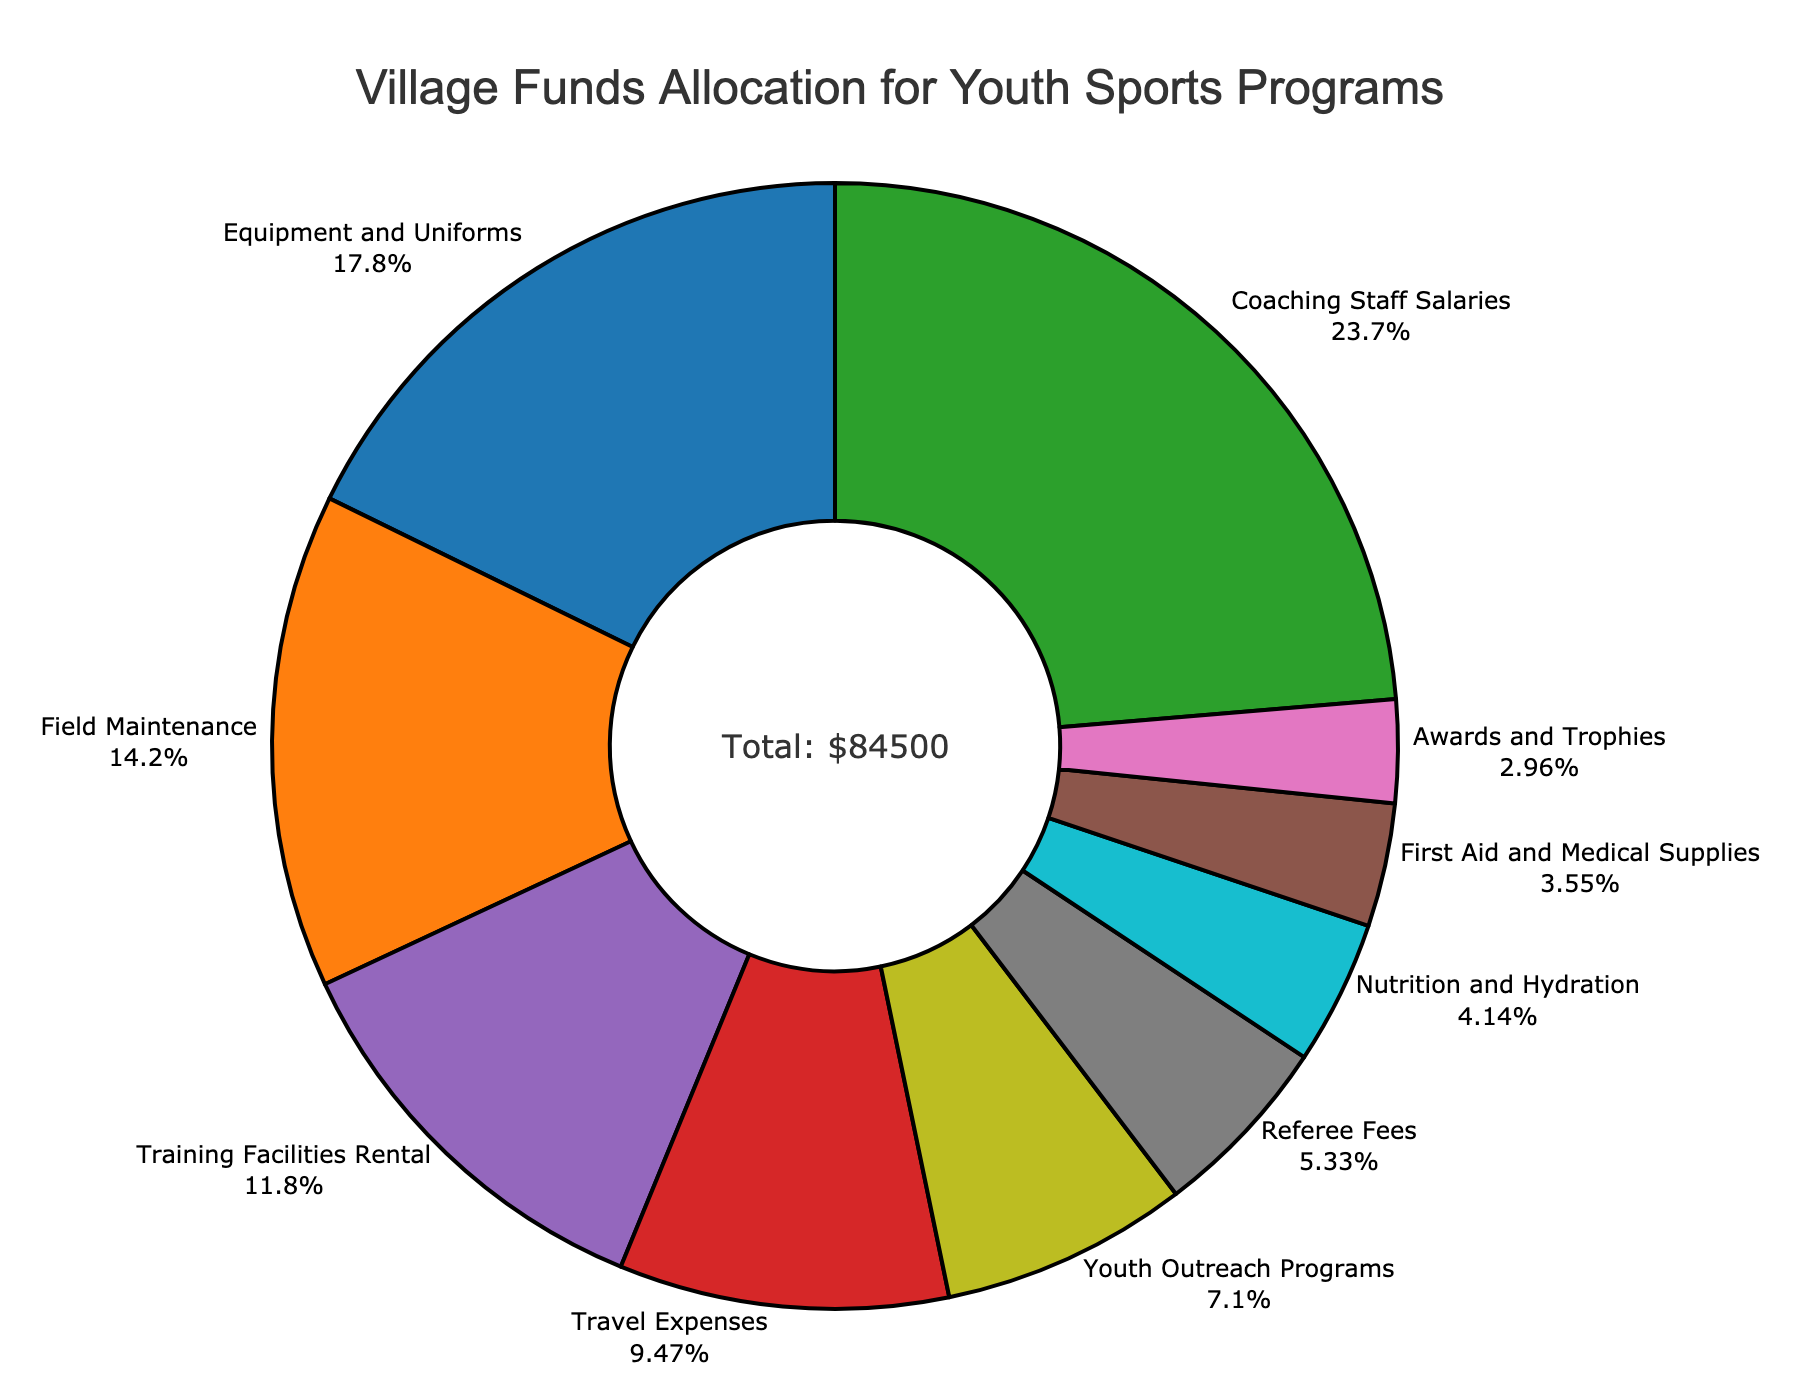Which category received the highest allocation of funds? By viewing the pie chart, identify the slice with the largest percentage which indicates the category with the highest allocation. The label and the percentage will tell you the category.
Answer: Coaching Staff Salaries How much money was allocated to First Aid and Medical Supplies? Look for the slice labeled "First Aid and Medical Supplies" and note the value indicated directly on the chart.
Answer: $3000 What is the total percentage of funds allocated to Equipment and Uniforms and Field Maintenance combined? Check the percentages of "Equipment and Uniforms" and "Field Maintenance" on the chart, then add them together. Equipment and Uniforms is 15.1% and Field Maintenance is 12.1%. 15.1% + 12.1% = 27.2%.
Answer: 27.2% Which expense category has a smaller allocation: Travel Expenses or Nutrition and Hydration? Compare the slices for "Travel Expenses" and "Nutrition and Hydration". The one with the smaller slice has the smaller allocation. The slices show Travel Expenses at 8% and Nutrition and Hydration at 3.5%.
Answer: Nutrition and Hydration What is the amount allocated for Youth Outreach Programs expressed as a percentage of the total funds? The pie chart will have a segment for "Youth Outreach Programs" with a percentage label, sum all percentages in this category and identify it. The slice is labeled 6% for Youth Outreach Programs.
Answer: 6% How much more was allocated to Coaching Staff Salaries compared to Training Facilities Rental? Coaching Staff Salaries received $20000, and Training Facilities Rental got $10000. Subtract $10000 (Training Facilities Rental) from $20000 (Coaching Staff Salaries). $20000 - $10000 = $10000.
Answer: $10000 If Equipment and Uniforms, Field Maintenance, and Referee Fees are combined, what is their total allocation amount? Add the amounts allocated to Equipment and Uniforms ($15000), Field Maintenance ($12000), and Referee Fees ($4500). Total is 15000 + 12000 + 4500 = $31500.
Answer: $31500 Which category has a closer allocation amount to the average allocation across all categories? First, calculate the average allocation by dividing the total funds ($84500) by the number of categories (10). The average is $84500 / 10 = $8450. Compare this average to each of the category amounts to find the closest amount. Training Facilities Rental ($10000) is closest to $8450.
Answer: Training Facilities Rental What is the smallest allocation amount and what percentage of the total does it represent? Identify the smallest allocation on the chart, which is labeled with the value and the corresponding percentage. The smallest amount is $2500 for Awards and Trophies, add the percentage marked on the pie.
Answer: $2500, 2.95% Is the allocation for Nutrition and Hydration greater or less than the combined allocation for First Aid and Medical Supplies and Referee Fees? Compare the allocation amounts: First Aid and Medical Supplies ($3000) and Referee Fees ($4500) together equal $7500, whereas Nutrition and Hydration is $3500. Since $3500 is less than $7500, it is less.
Answer: Less 